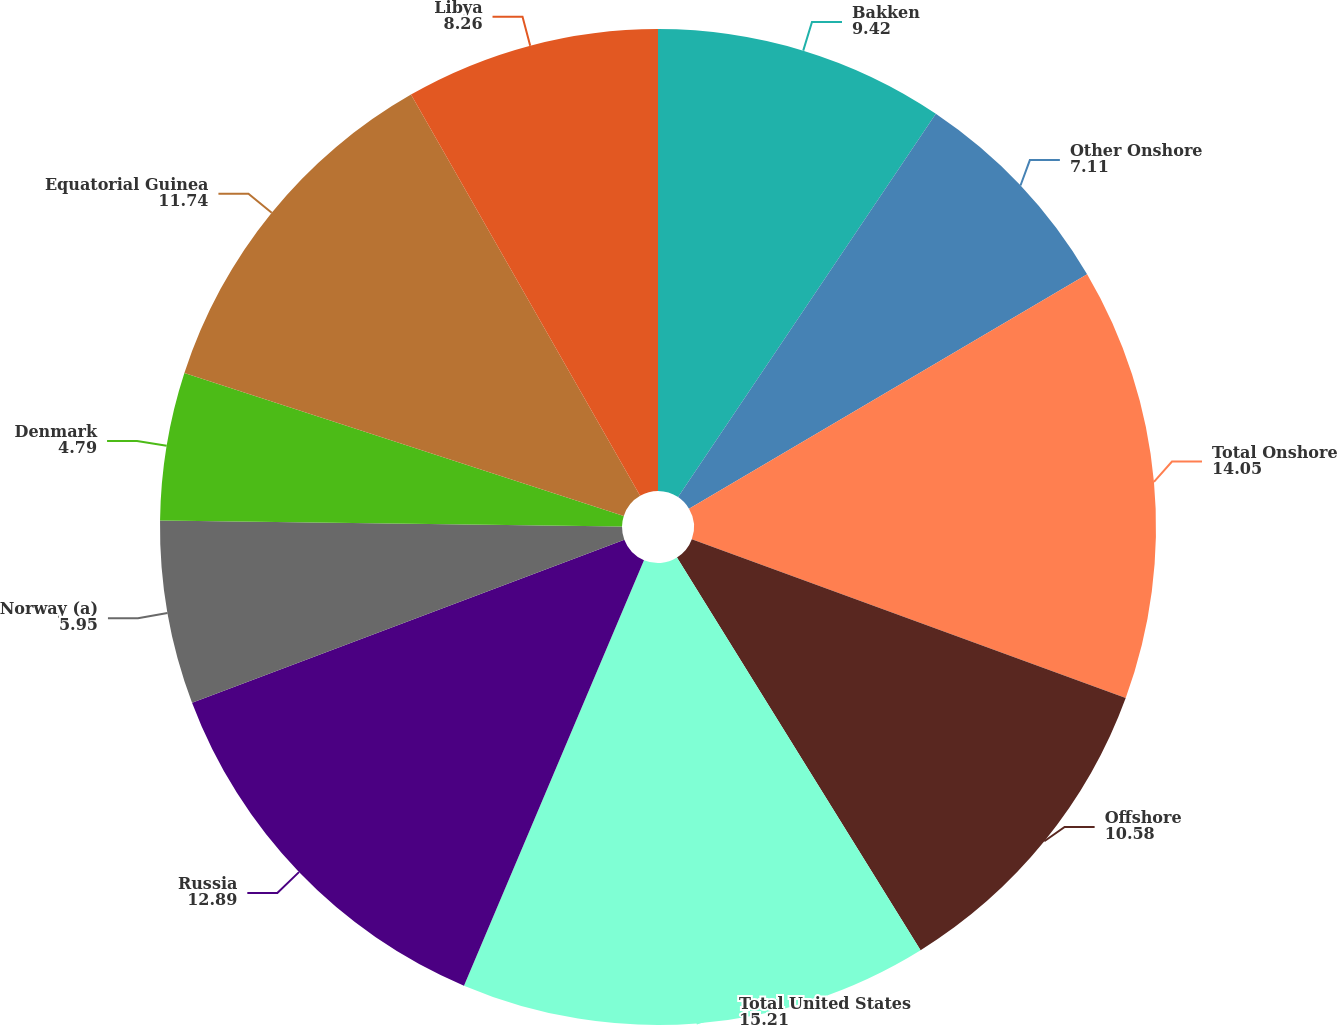<chart> <loc_0><loc_0><loc_500><loc_500><pie_chart><fcel>Bakken<fcel>Other Onshore<fcel>Total Onshore<fcel>Offshore<fcel>Total United States<fcel>Russia<fcel>Norway (a)<fcel>Denmark<fcel>Equatorial Guinea<fcel>Libya<nl><fcel>9.42%<fcel>7.11%<fcel>14.05%<fcel>10.58%<fcel>15.21%<fcel>12.89%<fcel>5.95%<fcel>4.79%<fcel>11.74%<fcel>8.26%<nl></chart> 